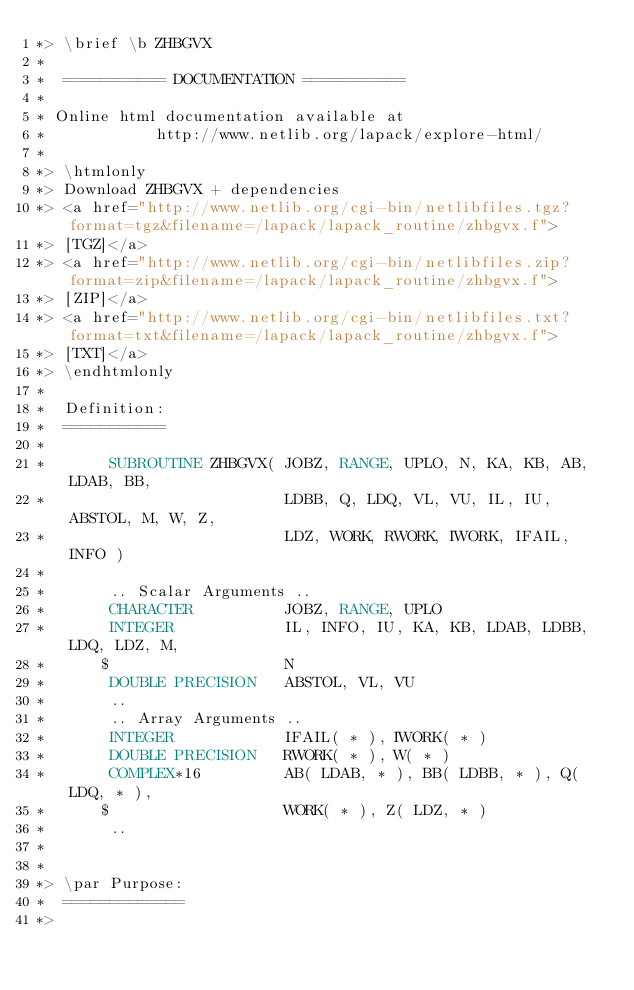Convert code to text. <code><loc_0><loc_0><loc_500><loc_500><_FORTRAN_>*> \brief \b ZHBGVX
*
*  =========== DOCUMENTATION ===========
*
* Online html documentation available at
*            http://www.netlib.org/lapack/explore-html/
*
*> \htmlonly
*> Download ZHBGVX + dependencies
*> <a href="http://www.netlib.org/cgi-bin/netlibfiles.tgz?format=tgz&filename=/lapack/lapack_routine/zhbgvx.f">
*> [TGZ]</a>
*> <a href="http://www.netlib.org/cgi-bin/netlibfiles.zip?format=zip&filename=/lapack/lapack_routine/zhbgvx.f">
*> [ZIP]</a>
*> <a href="http://www.netlib.org/cgi-bin/netlibfiles.txt?format=txt&filename=/lapack/lapack_routine/zhbgvx.f">
*> [TXT]</a>
*> \endhtmlonly
*
*  Definition:
*  ===========
*
*       SUBROUTINE ZHBGVX( JOBZ, RANGE, UPLO, N, KA, KB, AB, LDAB, BB,
*                          LDBB, Q, LDQ, VL, VU, IL, IU, ABSTOL, M, W, Z,
*                          LDZ, WORK, RWORK, IWORK, IFAIL, INFO )
*
*       .. Scalar Arguments ..
*       CHARACTER          JOBZ, RANGE, UPLO
*       INTEGER            IL, INFO, IU, KA, KB, LDAB, LDBB, LDQ, LDZ, M,
*      $                   N
*       DOUBLE PRECISION   ABSTOL, VL, VU
*       ..
*       .. Array Arguments ..
*       INTEGER            IFAIL( * ), IWORK( * )
*       DOUBLE PRECISION   RWORK( * ), W( * )
*       COMPLEX*16         AB( LDAB, * ), BB( LDBB, * ), Q( LDQ, * ),
*      $                   WORK( * ), Z( LDZ, * )
*       ..
*
*
*> \par Purpose:
*  =============
*></code> 